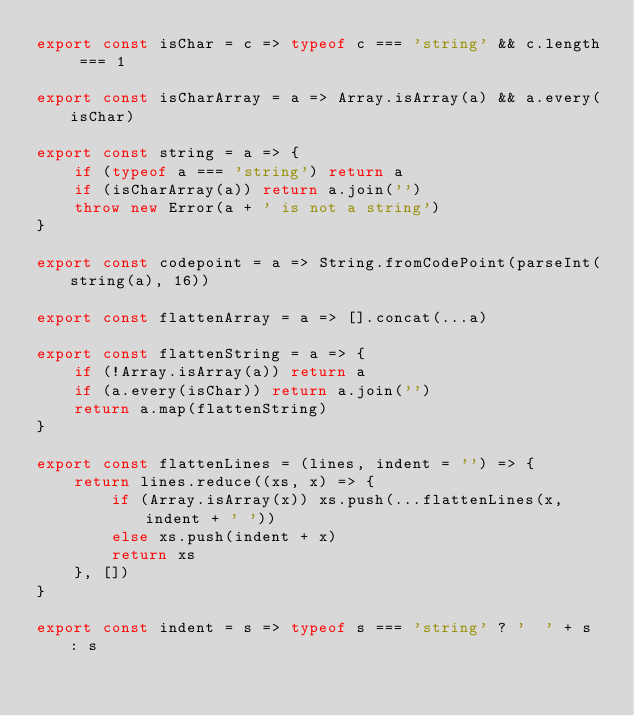Convert code to text. <code><loc_0><loc_0><loc_500><loc_500><_JavaScript_>export const isChar = c => typeof c === 'string' && c.length === 1

export const isCharArray = a => Array.isArray(a) && a.every(isChar)

export const string = a => {
	if (typeof a === 'string') return a
	if (isCharArray(a)) return a.join('')
	throw new Error(a + ' is not a string')
}

export const codepoint = a => String.fromCodePoint(parseInt(string(a), 16))

export const flattenArray = a => [].concat(...a)

export const flattenString = a => {
	if (!Array.isArray(a)) return a
	if (a.every(isChar)) return a.join('')
	return a.map(flattenString)
}

export const flattenLines = (lines, indent = '') => {
	return lines.reduce((xs, x) => {
		if (Array.isArray(x)) xs.push(...flattenLines(x, indent + ' '))
		else xs.push(indent + x)
		return xs
	}, [])
}

export const indent = s => typeof s === 'string' ? '  ' + s : s
</code> 